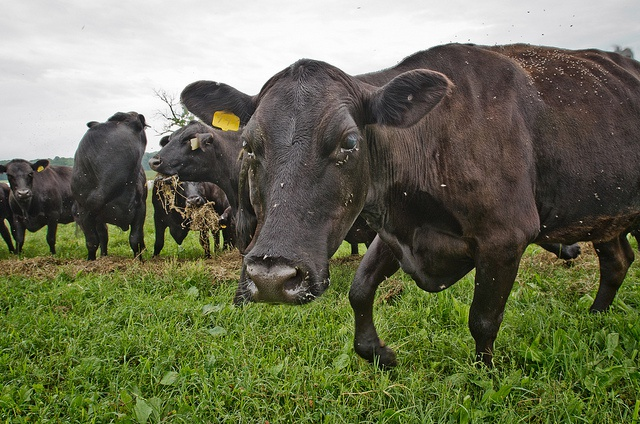Describe the objects in this image and their specific colors. I can see cow in lightgray, black, and gray tones, cow in lightgray, black, gray, and darkgreen tones, cow in lightgray, black, gray, and darkgray tones, cow in lightgray, black, gray, and darkgreen tones, and cow in lightgray, black, olive, gray, and tan tones in this image. 